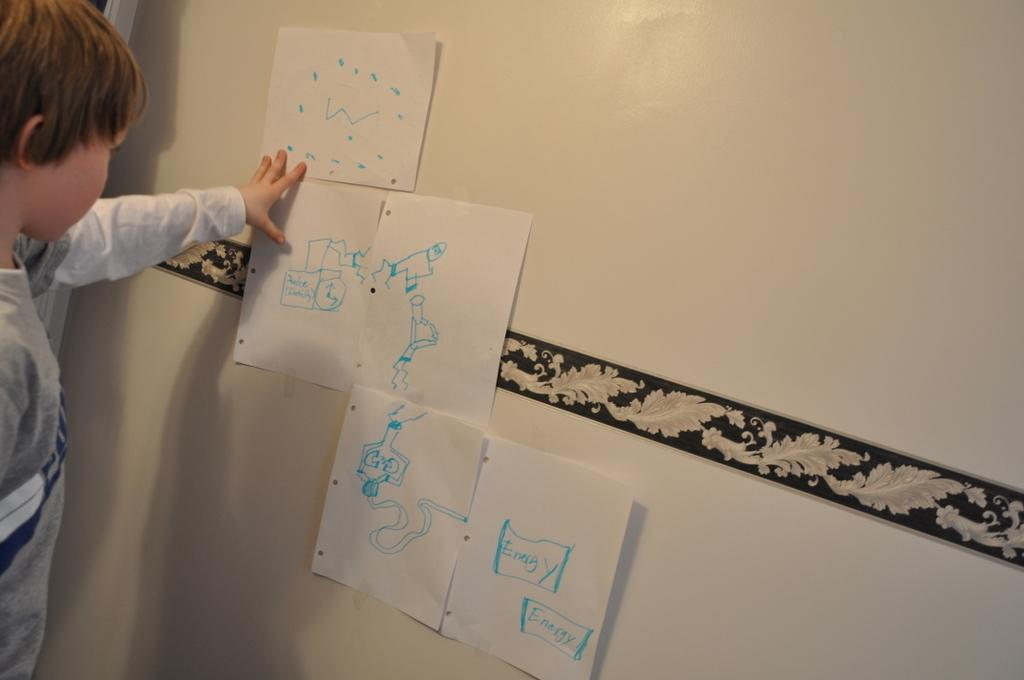<image>
Provide a brief description of the given image. A boy has several drawings on the wall and one of them has energy twice on it 